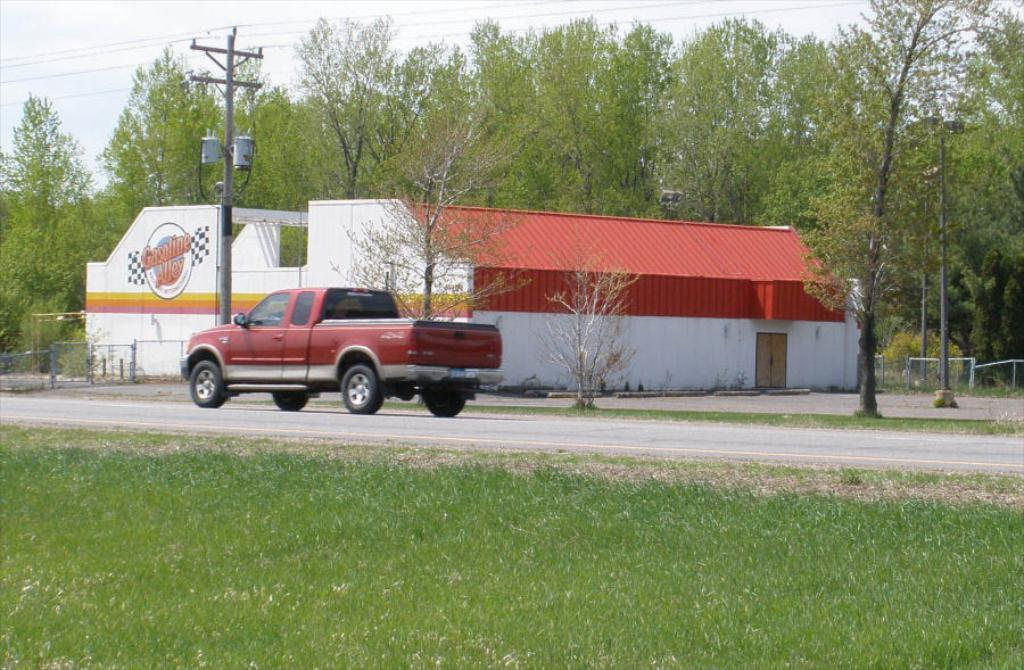What type of vegetation is on the ground in the image? There is green grass on the ground in the image. What can be seen on the ground besides the grass? There is a road in the image. What is on the road in the image? A car is present on the road in the image. What type of structure is visible in the image? There is a house in the image. What else can be seen in the image besides the grass, road, car, and house? There are trees in the image. What is visible at the top of the image? The sky is visible at the top of the image. How many umbrellas are being twisted in space in the image? There are no umbrellas or any indication of space in the image. 